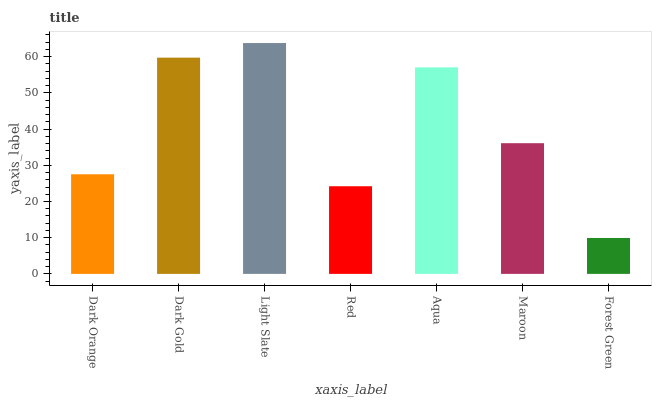Is Forest Green the minimum?
Answer yes or no. Yes. Is Light Slate the maximum?
Answer yes or no. Yes. Is Dark Gold the minimum?
Answer yes or no. No. Is Dark Gold the maximum?
Answer yes or no. No. Is Dark Gold greater than Dark Orange?
Answer yes or no. Yes. Is Dark Orange less than Dark Gold?
Answer yes or no. Yes. Is Dark Orange greater than Dark Gold?
Answer yes or no. No. Is Dark Gold less than Dark Orange?
Answer yes or no. No. Is Maroon the high median?
Answer yes or no. Yes. Is Maroon the low median?
Answer yes or no. Yes. Is Dark Gold the high median?
Answer yes or no. No. Is Dark Gold the low median?
Answer yes or no. No. 